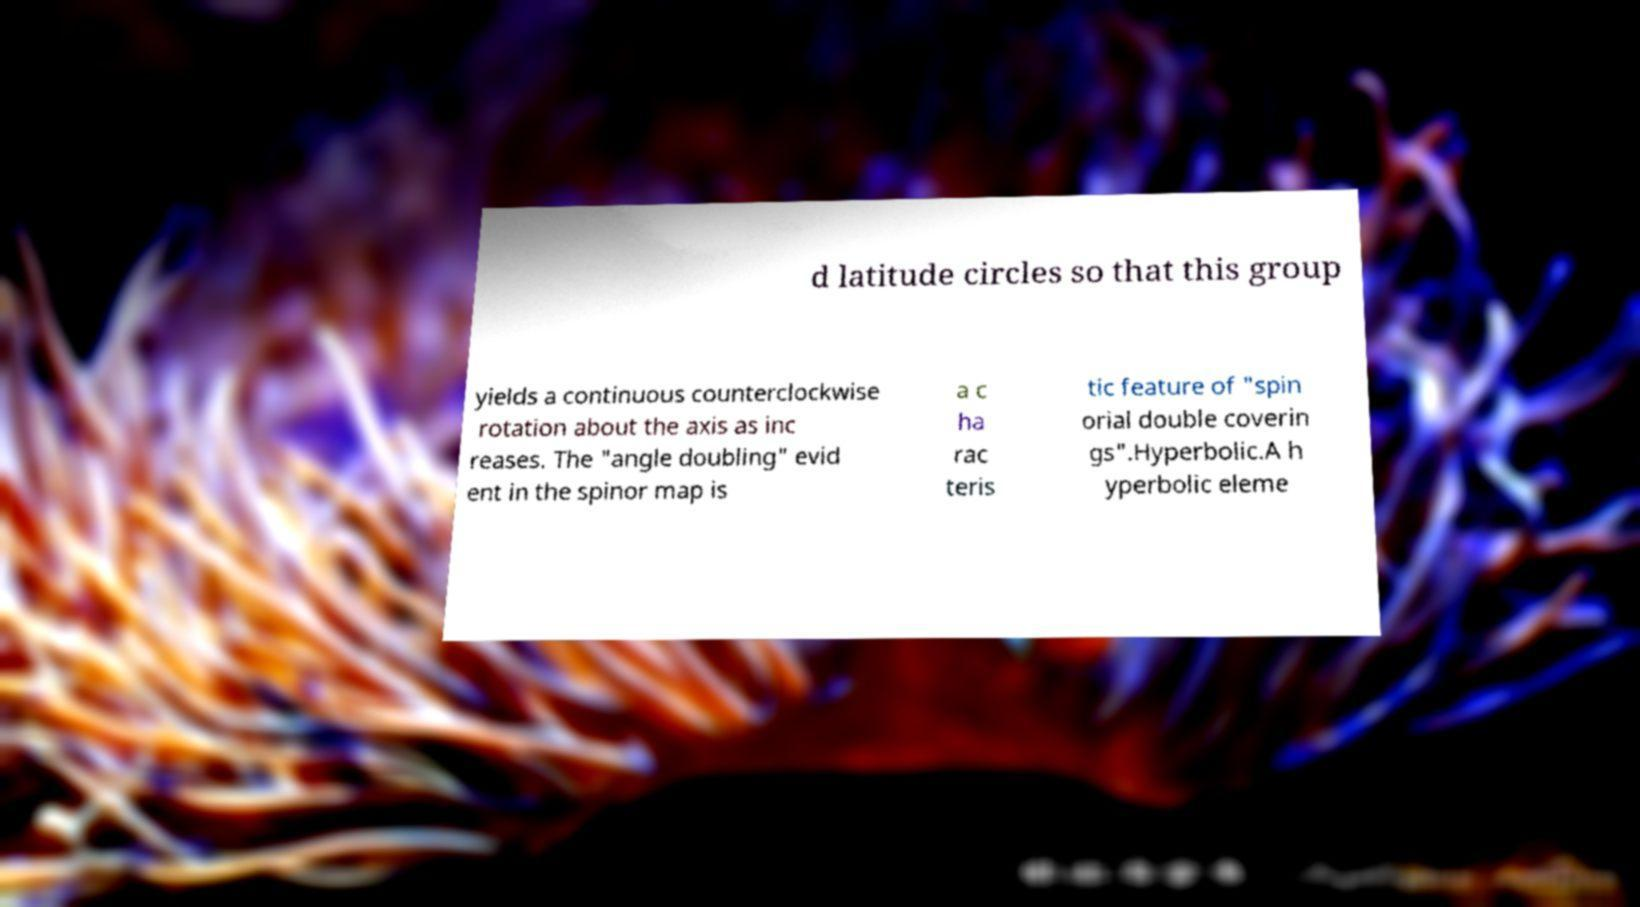I need the written content from this picture converted into text. Can you do that? d latitude circles so that this group yields a continuous counterclockwise rotation about the axis as inc reases. The "angle doubling" evid ent in the spinor map is a c ha rac teris tic feature of "spin orial double coverin gs".Hyperbolic.A h yperbolic eleme 